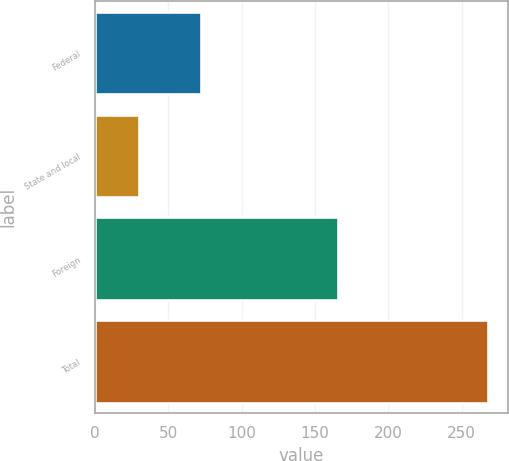Convert chart to OTSL. <chart><loc_0><loc_0><loc_500><loc_500><bar_chart><fcel>Federal<fcel>State and local<fcel>Foreign<fcel>Total<nl><fcel>72<fcel>30<fcel>166<fcel>268<nl></chart> 